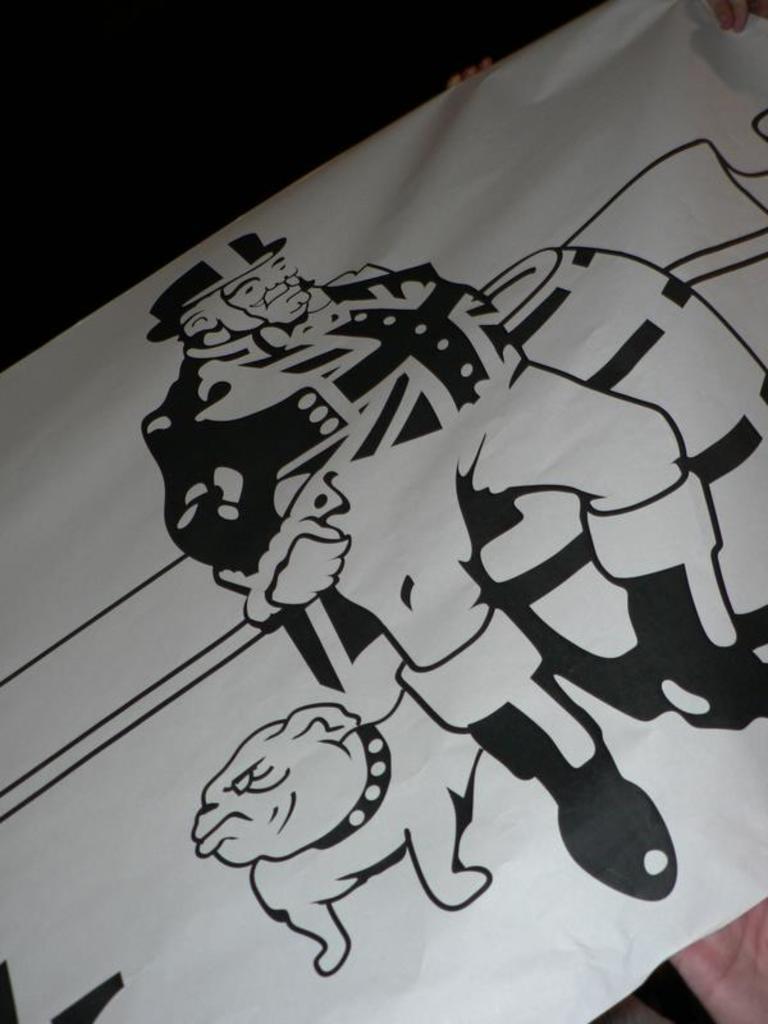Describe this image in one or two sentences. As we can see in the image there is a banner. On banner there is a drawing of a person and a dog. 